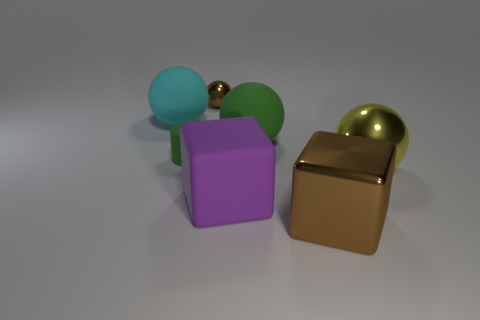Subtract all large spheres. How many spheres are left? 1 Add 1 big cyan balls. How many objects exist? 8 Subtract all blue spheres. Subtract all yellow cylinders. How many spheres are left? 4 Subtract all cubes. How many objects are left? 5 Subtract 1 brown spheres. How many objects are left? 6 Subtract all large purple matte blocks. Subtract all large metallic balls. How many objects are left? 5 Add 5 tiny brown things. How many tiny brown things are left? 6 Add 3 tiny red metallic objects. How many tiny red metallic objects exist? 3 